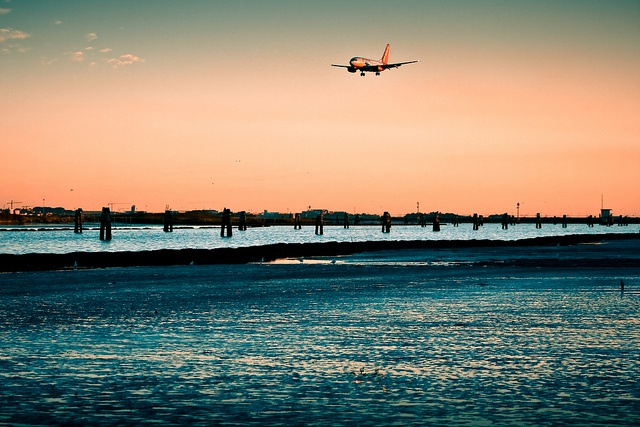Describe the objects in this image and their specific colors. I can see a airplane in teal, black, salmon, and tan tones in this image. 